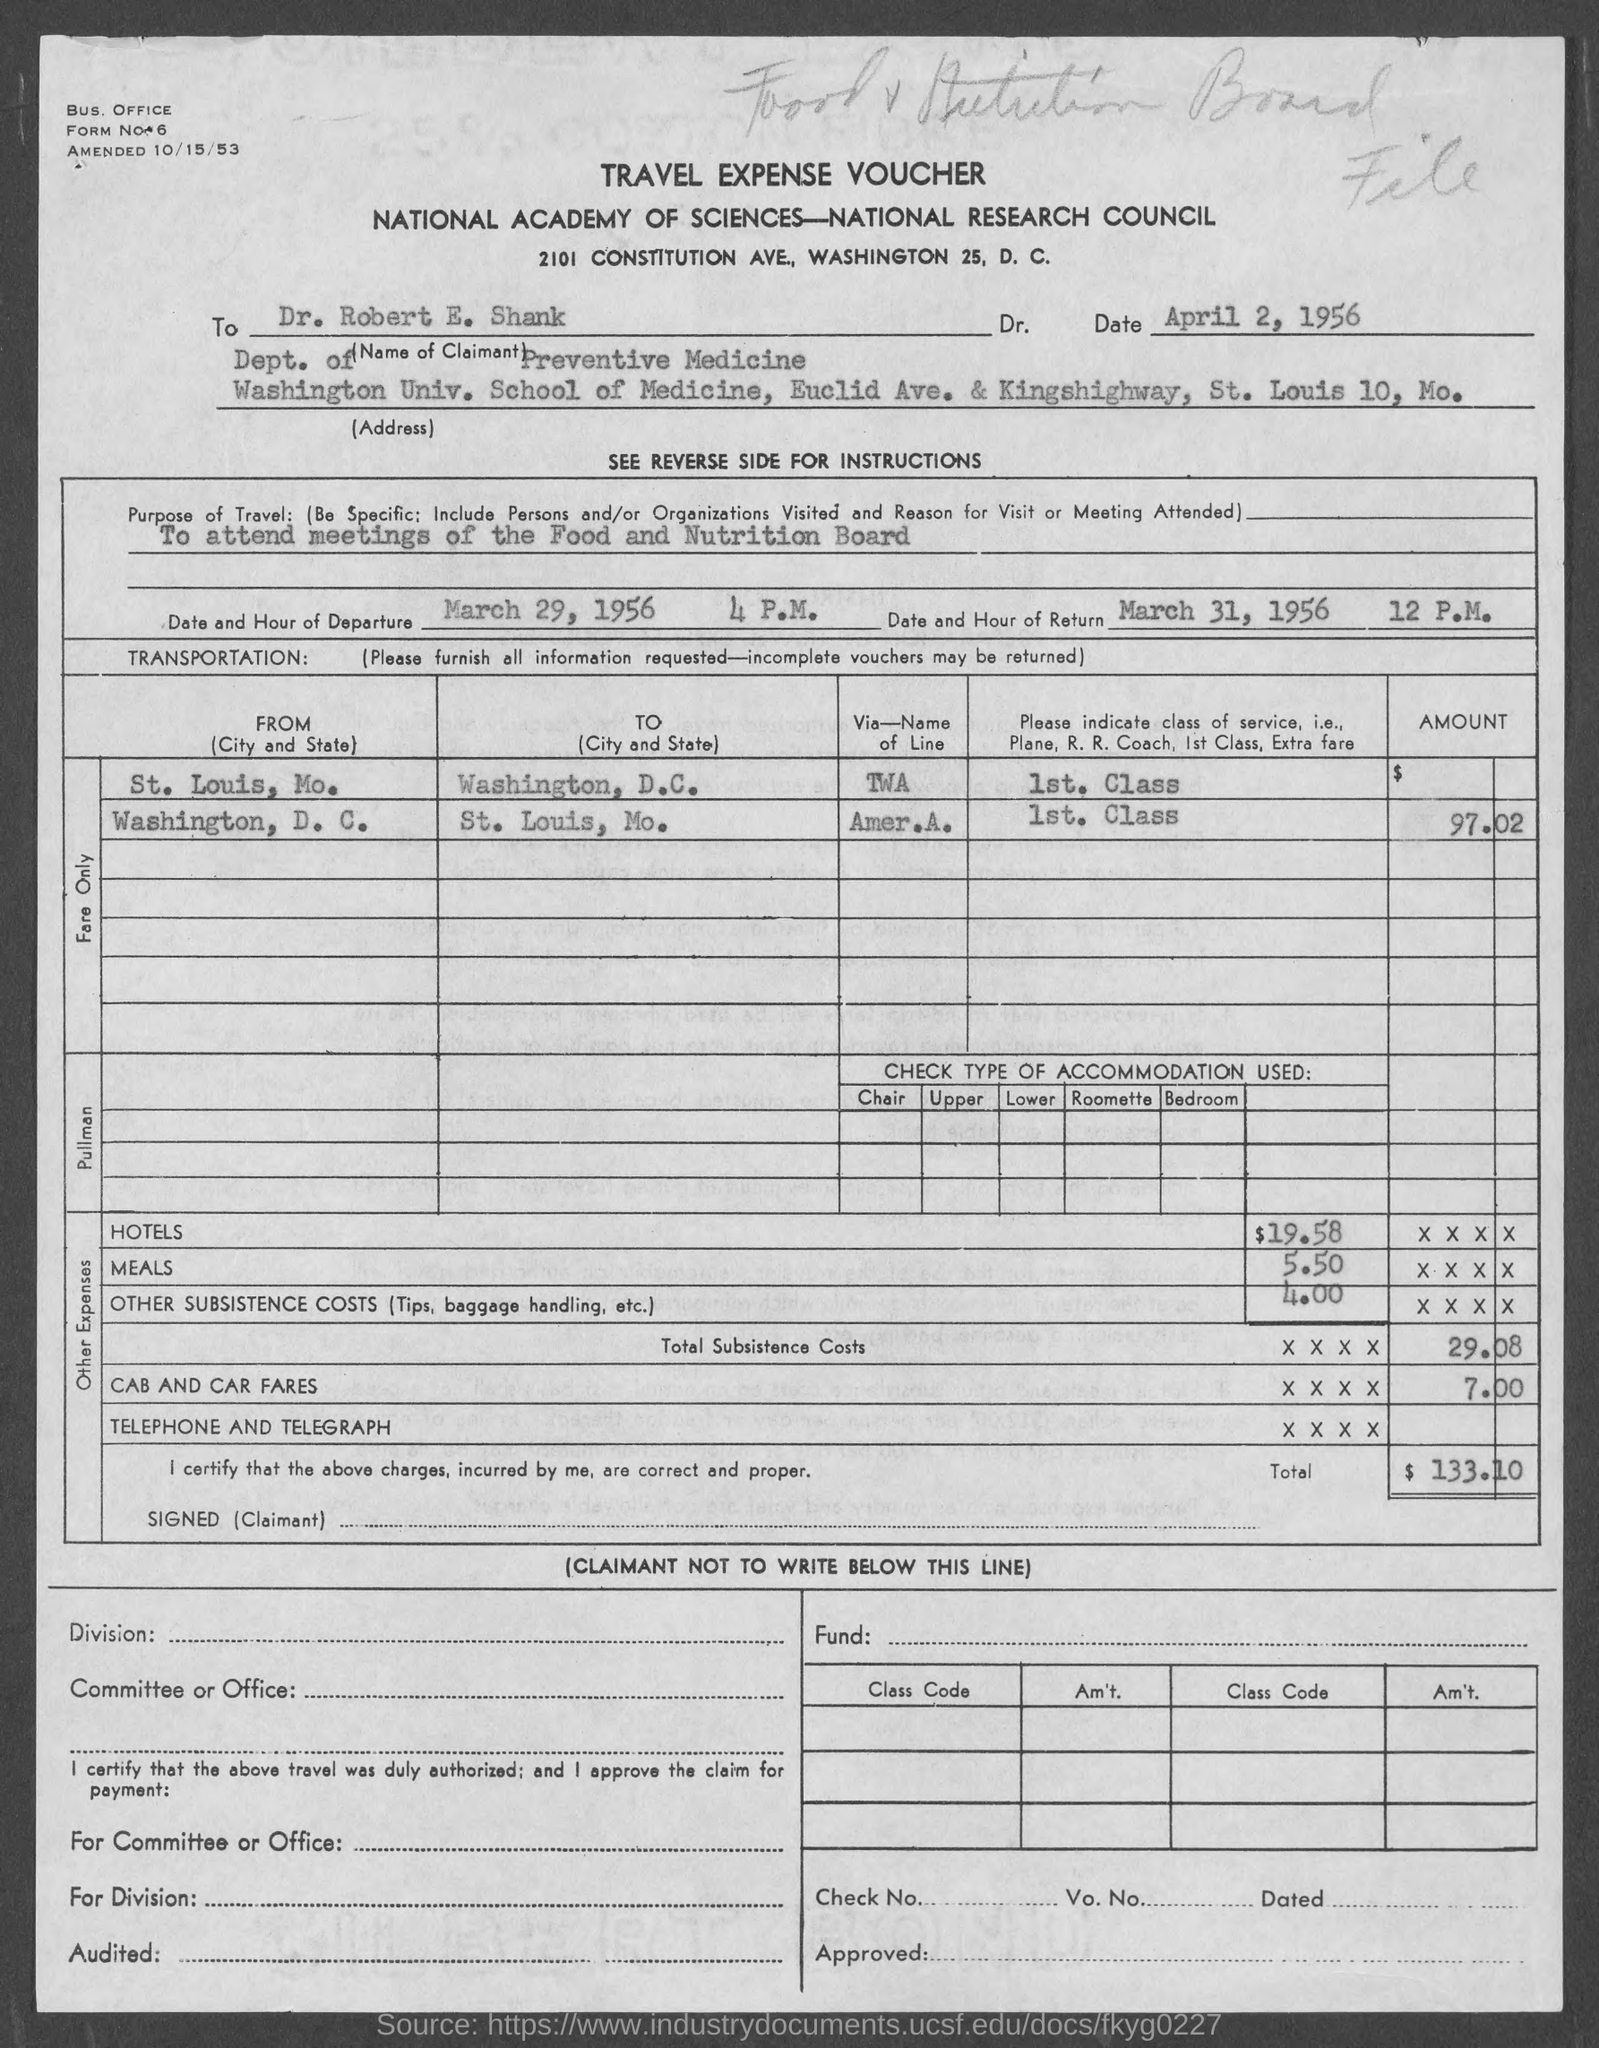Specify some key components in this picture. The form is addressed to Dr. Robert E. Shank. Dr. Robert is from the University of Washington. Dr. Robert E. Shank is from the department of Preventive Medicine. The document pertains to a travel expense voucher. The purpose of travel is to attend meetings of the Food and Nutrition Board. 